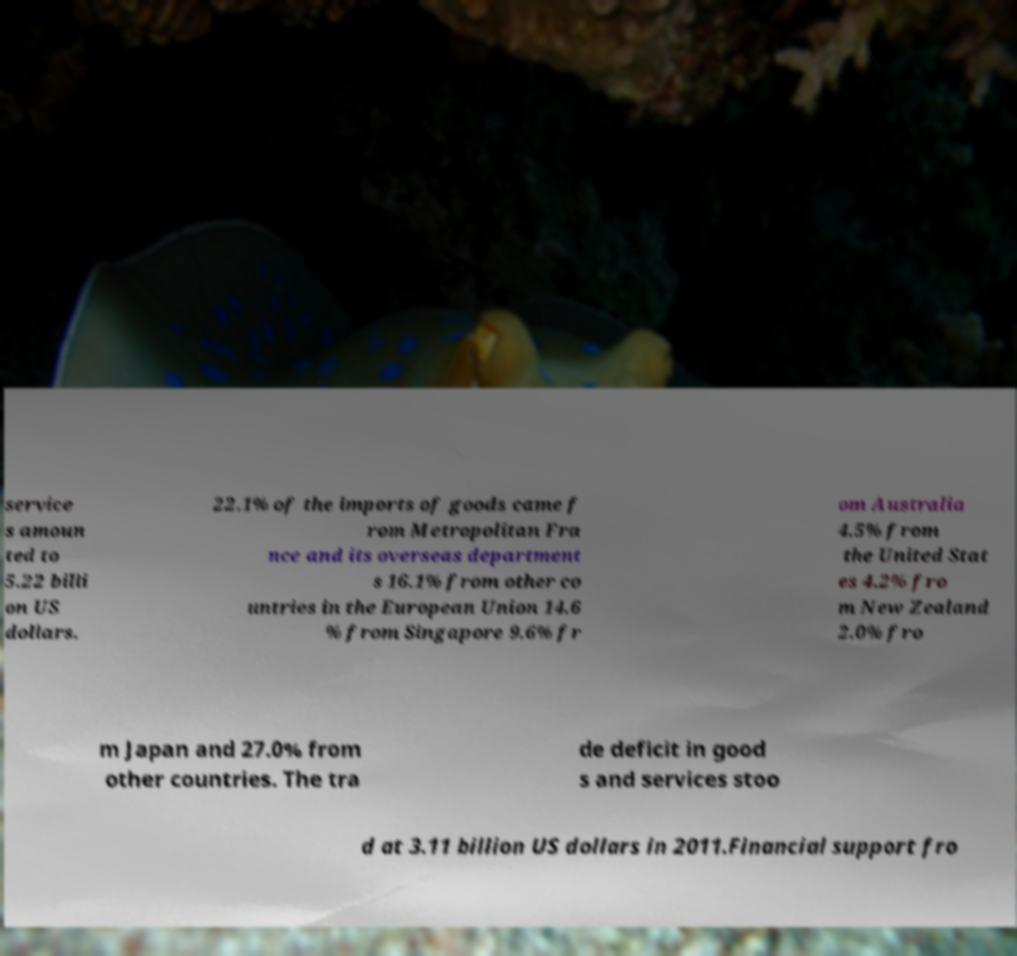Can you accurately transcribe the text from the provided image for me? service s amoun ted to 5.22 billi on US dollars. 22.1% of the imports of goods came f rom Metropolitan Fra nce and its overseas department s 16.1% from other co untries in the European Union 14.6 % from Singapore 9.6% fr om Australia 4.5% from the United Stat es 4.2% fro m New Zealand 2.0% fro m Japan and 27.0% from other countries. The tra de deficit in good s and services stoo d at 3.11 billion US dollars in 2011.Financial support fro 